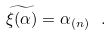<formula> <loc_0><loc_0><loc_500><loc_500>\widetilde { \xi ( \alpha ) } = \alpha _ { ( n ) } \ .</formula> 